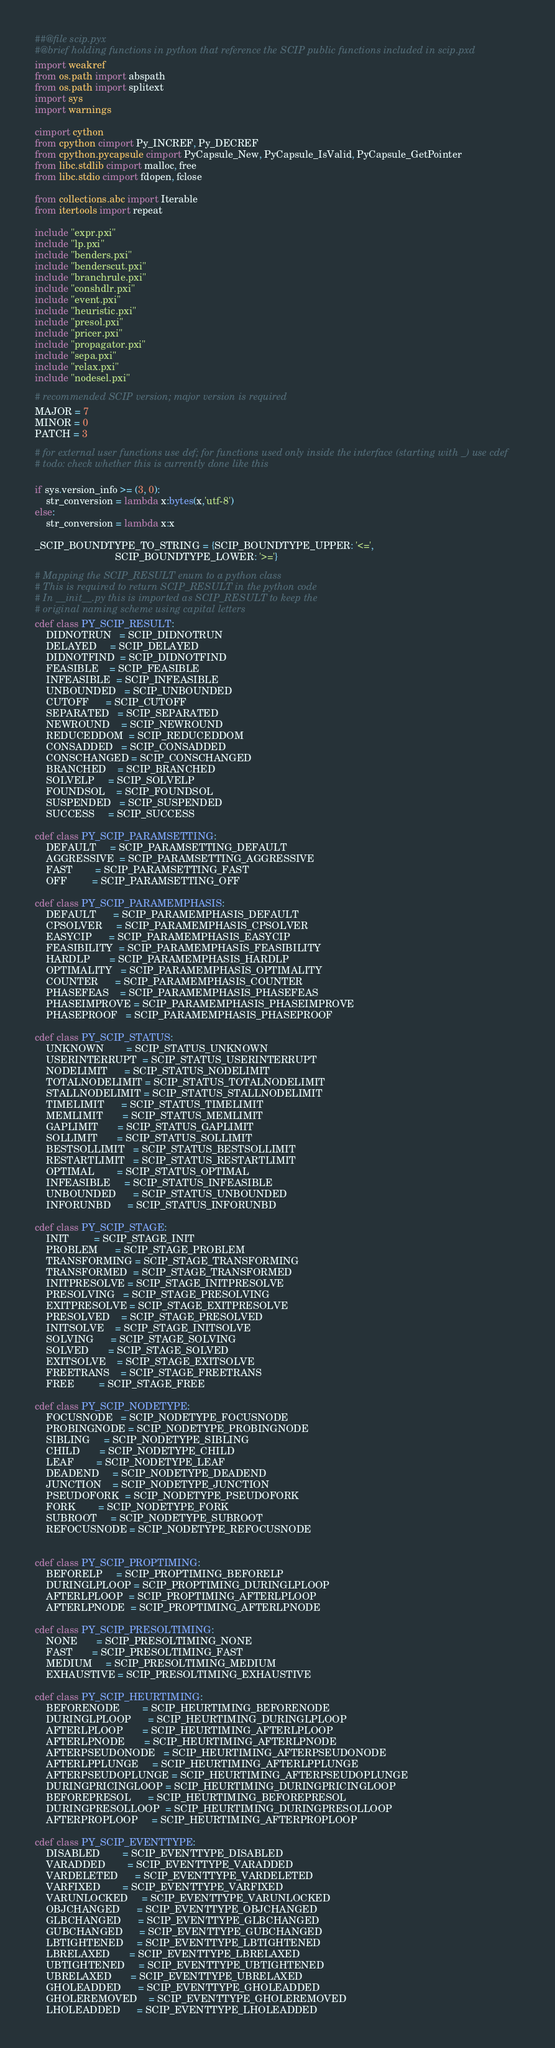Convert code to text. <code><loc_0><loc_0><loc_500><loc_500><_Cython_>##@file scip.pyx
#@brief holding functions in python that reference the SCIP public functions included in scip.pxd
import weakref
from os.path import abspath
from os.path import splitext
import sys
import warnings

cimport cython
from cpython cimport Py_INCREF, Py_DECREF
from cpython.pycapsule cimport PyCapsule_New, PyCapsule_IsValid, PyCapsule_GetPointer
from libc.stdlib cimport malloc, free
from libc.stdio cimport fdopen, fclose

from collections.abc import Iterable
from itertools import repeat

include "expr.pxi"
include "lp.pxi"
include "benders.pxi"
include "benderscut.pxi"
include "branchrule.pxi"
include "conshdlr.pxi"
include "event.pxi"
include "heuristic.pxi"
include "presol.pxi"
include "pricer.pxi"
include "propagator.pxi"
include "sepa.pxi"
include "relax.pxi"
include "nodesel.pxi"

# recommended SCIP version; major version is required
MAJOR = 7
MINOR = 0
PATCH = 3

# for external user functions use def; for functions used only inside the interface (starting with _) use cdef
# todo: check whether this is currently done like this

if sys.version_info >= (3, 0):
    str_conversion = lambda x:bytes(x,'utf-8')
else:
    str_conversion = lambda x:x

_SCIP_BOUNDTYPE_TO_STRING = {SCIP_BOUNDTYPE_UPPER: '<=',
                             SCIP_BOUNDTYPE_LOWER: '>='}

# Mapping the SCIP_RESULT enum to a python class
# This is required to return SCIP_RESULT in the python code
# In __init__.py this is imported as SCIP_RESULT to keep the
# original naming scheme using capital letters
cdef class PY_SCIP_RESULT:
    DIDNOTRUN   = SCIP_DIDNOTRUN
    DELAYED     = SCIP_DELAYED
    DIDNOTFIND  = SCIP_DIDNOTFIND
    FEASIBLE    = SCIP_FEASIBLE
    INFEASIBLE  = SCIP_INFEASIBLE
    UNBOUNDED   = SCIP_UNBOUNDED
    CUTOFF      = SCIP_CUTOFF
    SEPARATED   = SCIP_SEPARATED
    NEWROUND    = SCIP_NEWROUND
    REDUCEDDOM  = SCIP_REDUCEDDOM
    CONSADDED   = SCIP_CONSADDED
    CONSCHANGED = SCIP_CONSCHANGED
    BRANCHED    = SCIP_BRANCHED
    SOLVELP     = SCIP_SOLVELP
    FOUNDSOL    = SCIP_FOUNDSOL
    SUSPENDED   = SCIP_SUSPENDED
    SUCCESS     = SCIP_SUCCESS

cdef class PY_SCIP_PARAMSETTING:
    DEFAULT     = SCIP_PARAMSETTING_DEFAULT
    AGGRESSIVE  = SCIP_PARAMSETTING_AGGRESSIVE
    FAST        = SCIP_PARAMSETTING_FAST
    OFF         = SCIP_PARAMSETTING_OFF

cdef class PY_SCIP_PARAMEMPHASIS:
    DEFAULT      = SCIP_PARAMEMPHASIS_DEFAULT
    CPSOLVER     = SCIP_PARAMEMPHASIS_CPSOLVER
    EASYCIP      = SCIP_PARAMEMPHASIS_EASYCIP
    FEASIBILITY  = SCIP_PARAMEMPHASIS_FEASIBILITY
    HARDLP       = SCIP_PARAMEMPHASIS_HARDLP
    OPTIMALITY   = SCIP_PARAMEMPHASIS_OPTIMALITY
    COUNTER      = SCIP_PARAMEMPHASIS_COUNTER
    PHASEFEAS    = SCIP_PARAMEMPHASIS_PHASEFEAS
    PHASEIMPROVE = SCIP_PARAMEMPHASIS_PHASEIMPROVE
    PHASEPROOF   = SCIP_PARAMEMPHASIS_PHASEPROOF

cdef class PY_SCIP_STATUS:
    UNKNOWN        = SCIP_STATUS_UNKNOWN
    USERINTERRUPT  = SCIP_STATUS_USERINTERRUPT
    NODELIMIT      = SCIP_STATUS_NODELIMIT
    TOTALNODELIMIT = SCIP_STATUS_TOTALNODELIMIT
    STALLNODELIMIT = SCIP_STATUS_STALLNODELIMIT
    TIMELIMIT      = SCIP_STATUS_TIMELIMIT
    MEMLIMIT       = SCIP_STATUS_MEMLIMIT
    GAPLIMIT       = SCIP_STATUS_GAPLIMIT
    SOLLIMIT       = SCIP_STATUS_SOLLIMIT
    BESTSOLLIMIT   = SCIP_STATUS_BESTSOLLIMIT
    RESTARTLIMIT   = SCIP_STATUS_RESTARTLIMIT
    OPTIMAL        = SCIP_STATUS_OPTIMAL
    INFEASIBLE     = SCIP_STATUS_INFEASIBLE
    UNBOUNDED      = SCIP_STATUS_UNBOUNDED
    INFORUNBD      = SCIP_STATUS_INFORUNBD

cdef class PY_SCIP_STAGE:
    INIT         = SCIP_STAGE_INIT
    PROBLEM      = SCIP_STAGE_PROBLEM
    TRANSFORMING = SCIP_STAGE_TRANSFORMING
    TRANSFORMED  = SCIP_STAGE_TRANSFORMED
    INITPRESOLVE = SCIP_STAGE_INITPRESOLVE
    PRESOLVING   = SCIP_STAGE_PRESOLVING
    EXITPRESOLVE = SCIP_STAGE_EXITPRESOLVE
    PRESOLVED    = SCIP_STAGE_PRESOLVED
    INITSOLVE    = SCIP_STAGE_INITSOLVE
    SOLVING      = SCIP_STAGE_SOLVING
    SOLVED       = SCIP_STAGE_SOLVED
    EXITSOLVE    = SCIP_STAGE_EXITSOLVE
    FREETRANS    = SCIP_STAGE_FREETRANS
    FREE         = SCIP_STAGE_FREE

cdef class PY_SCIP_NODETYPE:
    FOCUSNODE   = SCIP_NODETYPE_FOCUSNODE
    PROBINGNODE = SCIP_NODETYPE_PROBINGNODE
    SIBLING     = SCIP_NODETYPE_SIBLING
    CHILD       = SCIP_NODETYPE_CHILD
    LEAF        = SCIP_NODETYPE_LEAF
    DEADEND     = SCIP_NODETYPE_DEADEND
    JUNCTION    = SCIP_NODETYPE_JUNCTION
    PSEUDOFORK  = SCIP_NODETYPE_PSEUDOFORK
    FORK        = SCIP_NODETYPE_FORK
    SUBROOT     = SCIP_NODETYPE_SUBROOT
    REFOCUSNODE = SCIP_NODETYPE_REFOCUSNODE


cdef class PY_SCIP_PROPTIMING:
    BEFORELP     = SCIP_PROPTIMING_BEFORELP
    DURINGLPLOOP = SCIP_PROPTIMING_DURINGLPLOOP
    AFTERLPLOOP  = SCIP_PROPTIMING_AFTERLPLOOP
    AFTERLPNODE  = SCIP_PROPTIMING_AFTERLPNODE

cdef class PY_SCIP_PRESOLTIMING:
    NONE       = SCIP_PRESOLTIMING_NONE
    FAST       = SCIP_PRESOLTIMING_FAST
    MEDIUM     = SCIP_PRESOLTIMING_MEDIUM
    EXHAUSTIVE = SCIP_PRESOLTIMING_EXHAUSTIVE

cdef class PY_SCIP_HEURTIMING:
    BEFORENODE        = SCIP_HEURTIMING_BEFORENODE
    DURINGLPLOOP      = SCIP_HEURTIMING_DURINGLPLOOP
    AFTERLPLOOP       = SCIP_HEURTIMING_AFTERLPLOOP
    AFTERLPNODE       = SCIP_HEURTIMING_AFTERLPNODE
    AFTERPSEUDONODE   = SCIP_HEURTIMING_AFTERPSEUDONODE
    AFTERLPPLUNGE     = SCIP_HEURTIMING_AFTERLPPLUNGE
    AFTERPSEUDOPLUNGE = SCIP_HEURTIMING_AFTERPSEUDOPLUNGE
    DURINGPRICINGLOOP = SCIP_HEURTIMING_DURINGPRICINGLOOP
    BEFOREPRESOL      = SCIP_HEURTIMING_BEFOREPRESOL
    DURINGPRESOLLOOP  = SCIP_HEURTIMING_DURINGPRESOLLOOP
    AFTERPROPLOOP     = SCIP_HEURTIMING_AFTERPROPLOOP

cdef class PY_SCIP_EVENTTYPE:
    DISABLED        = SCIP_EVENTTYPE_DISABLED
    VARADDED        = SCIP_EVENTTYPE_VARADDED
    VARDELETED      = SCIP_EVENTTYPE_VARDELETED
    VARFIXED        = SCIP_EVENTTYPE_VARFIXED
    VARUNLOCKED     = SCIP_EVENTTYPE_VARUNLOCKED
    OBJCHANGED      = SCIP_EVENTTYPE_OBJCHANGED
    GLBCHANGED      = SCIP_EVENTTYPE_GLBCHANGED
    GUBCHANGED      = SCIP_EVENTTYPE_GUBCHANGED
    LBTIGHTENED     = SCIP_EVENTTYPE_LBTIGHTENED
    LBRELAXED       = SCIP_EVENTTYPE_LBRELAXED
    UBTIGHTENED     = SCIP_EVENTTYPE_UBTIGHTENED
    UBRELAXED       = SCIP_EVENTTYPE_UBRELAXED
    GHOLEADDED      = SCIP_EVENTTYPE_GHOLEADDED
    GHOLEREMOVED    = SCIP_EVENTTYPE_GHOLEREMOVED
    LHOLEADDED      = SCIP_EVENTTYPE_LHOLEADDED</code> 